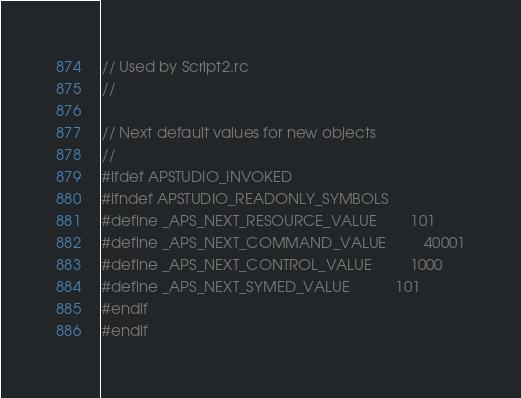Convert code to text. <code><loc_0><loc_0><loc_500><loc_500><_C_>// Used by Script2.rc
//

// Next default values for new objects
// 
#ifdef APSTUDIO_INVOKED
#ifndef APSTUDIO_READONLY_SYMBOLS
#define _APS_NEXT_RESOURCE_VALUE        101
#define _APS_NEXT_COMMAND_VALUE         40001
#define _APS_NEXT_CONTROL_VALUE         1000
#define _APS_NEXT_SYMED_VALUE           101
#endif
#endif
</code> 